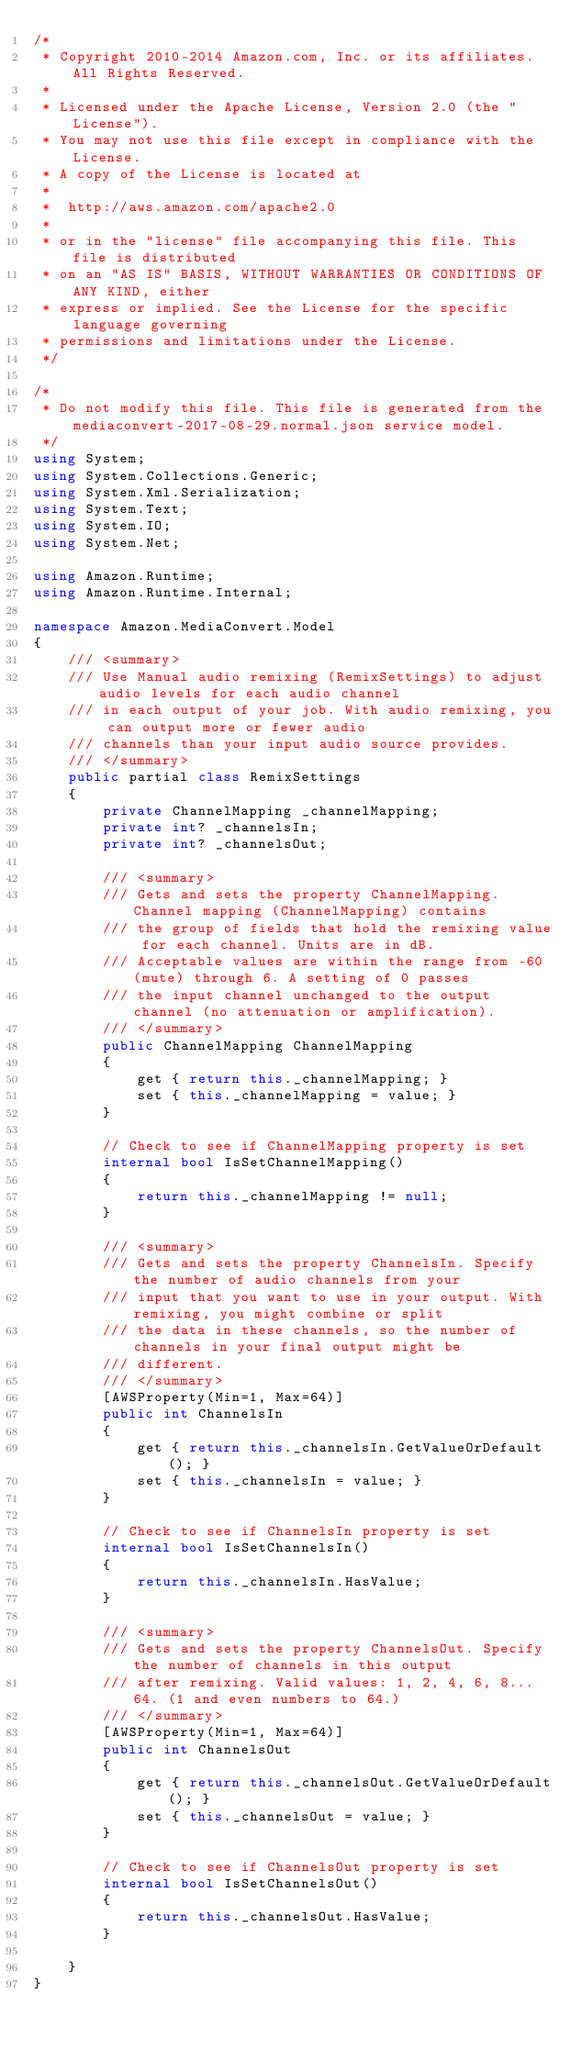Convert code to text. <code><loc_0><loc_0><loc_500><loc_500><_C#_>/*
 * Copyright 2010-2014 Amazon.com, Inc. or its affiliates. All Rights Reserved.
 * 
 * Licensed under the Apache License, Version 2.0 (the "License").
 * You may not use this file except in compliance with the License.
 * A copy of the License is located at
 * 
 *  http://aws.amazon.com/apache2.0
 * 
 * or in the "license" file accompanying this file. This file is distributed
 * on an "AS IS" BASIS, WITHOUT WARRANTIES OR CONDITIONS OF ANY KIND, either
 * express or implied. See the License for the specific language governing
 * permissions and limitations under the License.
 */

/*
 * Do not modify this file. This file is generated from the mediaconvert-2017-08-29.normal.json service model.
 */
using System;
using System.Collections.Generic;
using System.Xml.Serialization;
using System.Text;
using System.IO;
using System.Net;

using Amazon.Runtime;
using Amazon.Runtime.Internal;

namespace Amazon.MediaConvert.Model
{
    /// <summary>
    /// Use Manual audio remixing (RemixSettings) to adjust audio levels for each audio channel
    /// in each output of your job. With audio remixing, you can output more or fewer audio
    /// channels than your input audio source provides.
    /// </summary>
    public partial class RemixSettings
    {
        private ChannelMapping _channelMapping;
        private int? _channelsIn;
        private int? _channelsOut;

        /// <summary>
        /// Gets and sets the property ChannelMapping. Channel mapping (ChannelMapping) contains
        /// the group of fields that hold the remixing value for each channel. Units are in dB.
        /// Acceptable values are within the range from -60 (mute) through 6. A setting of 0 passes
        /// the input channel unchanged to the output channel (no attenuation or amplification).
        /// </summary>
        public ChannelMapping ChannelMapping
        {
            get { return this._channelMapping; }
            set { this._channelMapping = value; }
        }

        // Check to see if ChannelMapping property is set
        internal bool IsSetChannelMapping()
        {
            return this._channelMapping != null;
        }

        /// <summary>
        /// Gets and sets the property ChannelsIn. Specify the number of audio channels from your
        /// input that you want to use in your output. With remixing, you might combine or split
        /// the data in these channels, so the number of channels in your final output might be
        /// different.
        /// </summary>
        [AWSProperty(Min=1, Max=64)]
        public int ChannelsIn
        {
            get { return this._channelsIn.GetValueOrDefault(); }
            set { this._channelsIn = value; }
        }

        // Check to see if ChannelsIn property is set
        internal bool IsSetChannelsIn()
        {
            return this._channelsIn.HasValue; 
        }

        /// <summary>
        /// Gets and sets the property ChannelsOut. Specify the number of channels in this output
        /// after remixing. Valid values: 1, 2, 4, 6, 8... 64. (1 and even numbers to 64.)
        /// </summary>
        [AWSProperty(Min=1, Max=64)]
        public int ChannelsOut
        {
            get { return this._channelsOut.GetValueOrDefault(); }
            set { this._channelsOut = value; }
        }

        // Check to see if ChannelsOut property is set
        internal bool IsSetChannelsOut()
        {
            return this._channelsOut.HasValue; 
        }

    }
}</code> 